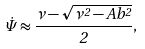Convert formula to latex. <formula><loc_0><loc_0><loc_500><loc_500>\dot { \Psi } \approx \frac { \nu - \sqrt { \nu ^ { 2 } - A b ^ { 2 } } } { 2 } ,</formula> 